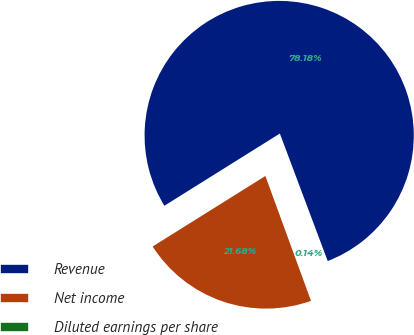<chart> <loc_0><loc_0><loc_500><loc_500><pie_chart><fcel>Revenue<fcel>Net income<fcel>Diluted earnings per share<nl><fcel>78.18%<fcel>21.68%<fcel>0.14%<nl></chart> 